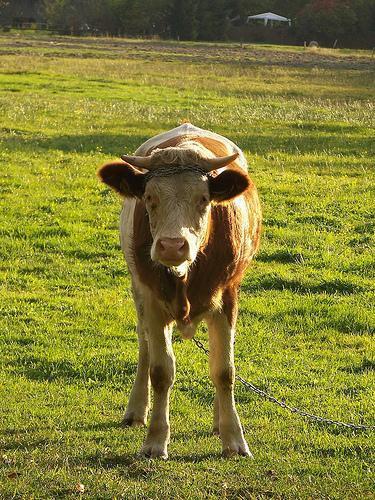How many animals are there?
Give a very brief answer. 1. 